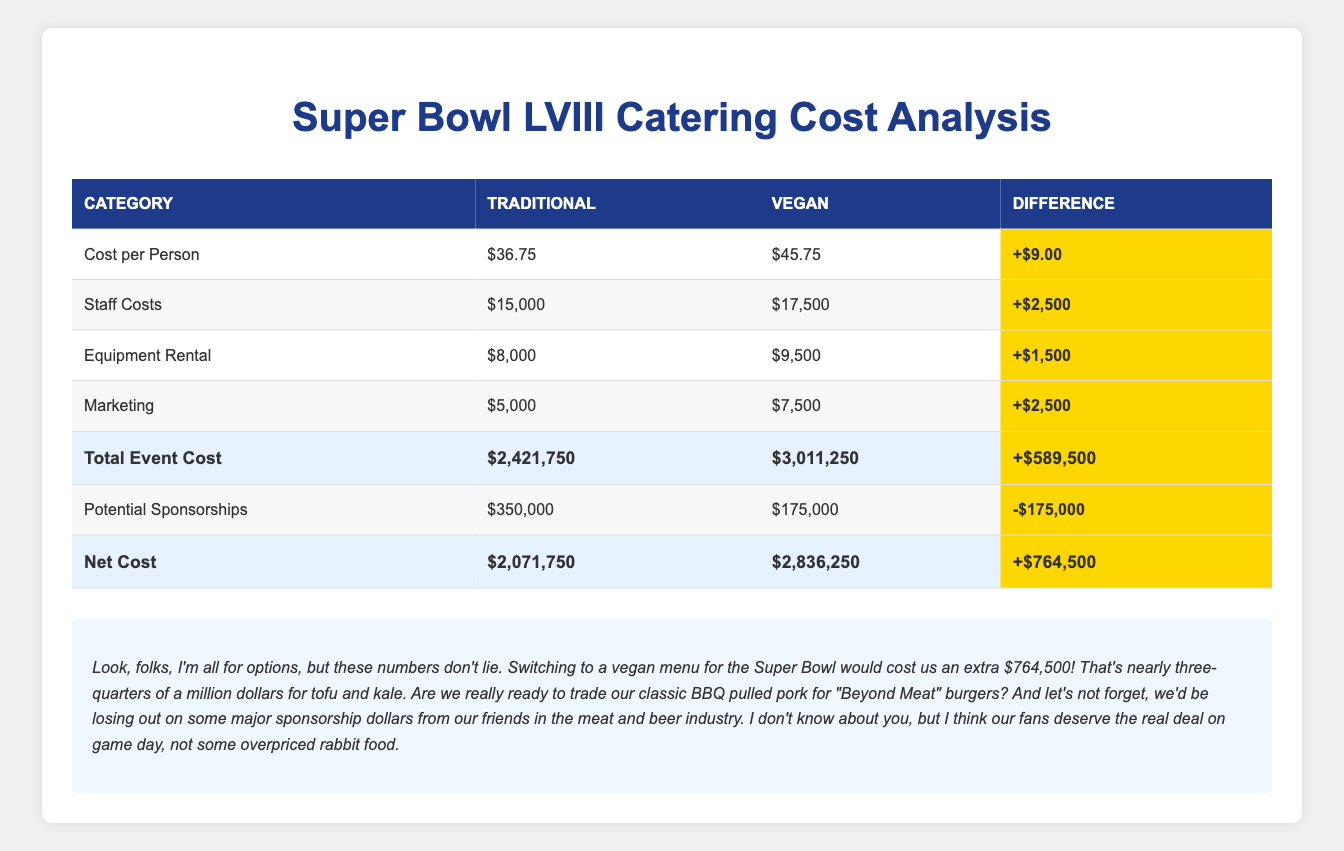What is the total cost per person for traditional catering? The table shows that under the traditional category, the cost per person is listed as $36.75.
Answer: $36.75 What is the total event cost difference between traditional and vegan options? In the table, the total event cost for traditional catering is $2,421,750 and for vegan options it is $3,011,250. The difference is calculated as $3,011,250 - $2,421,750 = $589,500.
Answer: $589,500 Is the cost per person for vegan catering higher than for traditional catering? The table indicates that the cost per person for vegan catering is $45.75 while for traditional it is $36.75. Since $45.75 is higher than $36.75, the answer is yes.
Answer: Yes What is the total amount of potential sponsorships for traditional catering? Cumulatively, the table lists two sponsorships under traditional: Tyson Foods for $150,000 and Anheuser-Busch for $200,000. Adding these amounts gives $150,000 + $200,000 = $350,000.
Answer: $350,000 How much more do we need to spend on staff for vegan catering compared to traditional catering? According to the table, staff costs are $15,000 for traditional and $17,500 for vegan. The difference is $17,500 - $15,000 = $2,500.
Answer: $2,500 If we calculate the net cost for the event with traditional catering, what is that figure? From the table, the total event cost for traditional catering is $2,421,750 and potential sponsorships total $350,000. The net cost is therefore $2,421,750 - $350,000 = $2,071,750.
Answer: $2,071,750 Would switching to vegan options affect the net cost positively or negatively? The net cost for vegan catering is $2,836,250 as opposed to $2,071,750 for traditional. The difference calculated as $2,836,250 - $2,071,750 = $764,500 indicates that switching to vegan options results in increased cost, so it is negative.
Answer: Negative What is the total equipment rental cost for vegan catering? The table shows that the equipment rental cost for vegan catering is $9,500.
Answer: $9,500 How much higher is the marketing cost for vegan catering compared to traditional catering? The table notes a marketing cost of $5,000 for traditional and $7,500 for vegan. The difference is $7,500 - $5,000 = $2,500, indicating that vegan marketing costs an additional amount.
Answer: $2,500 